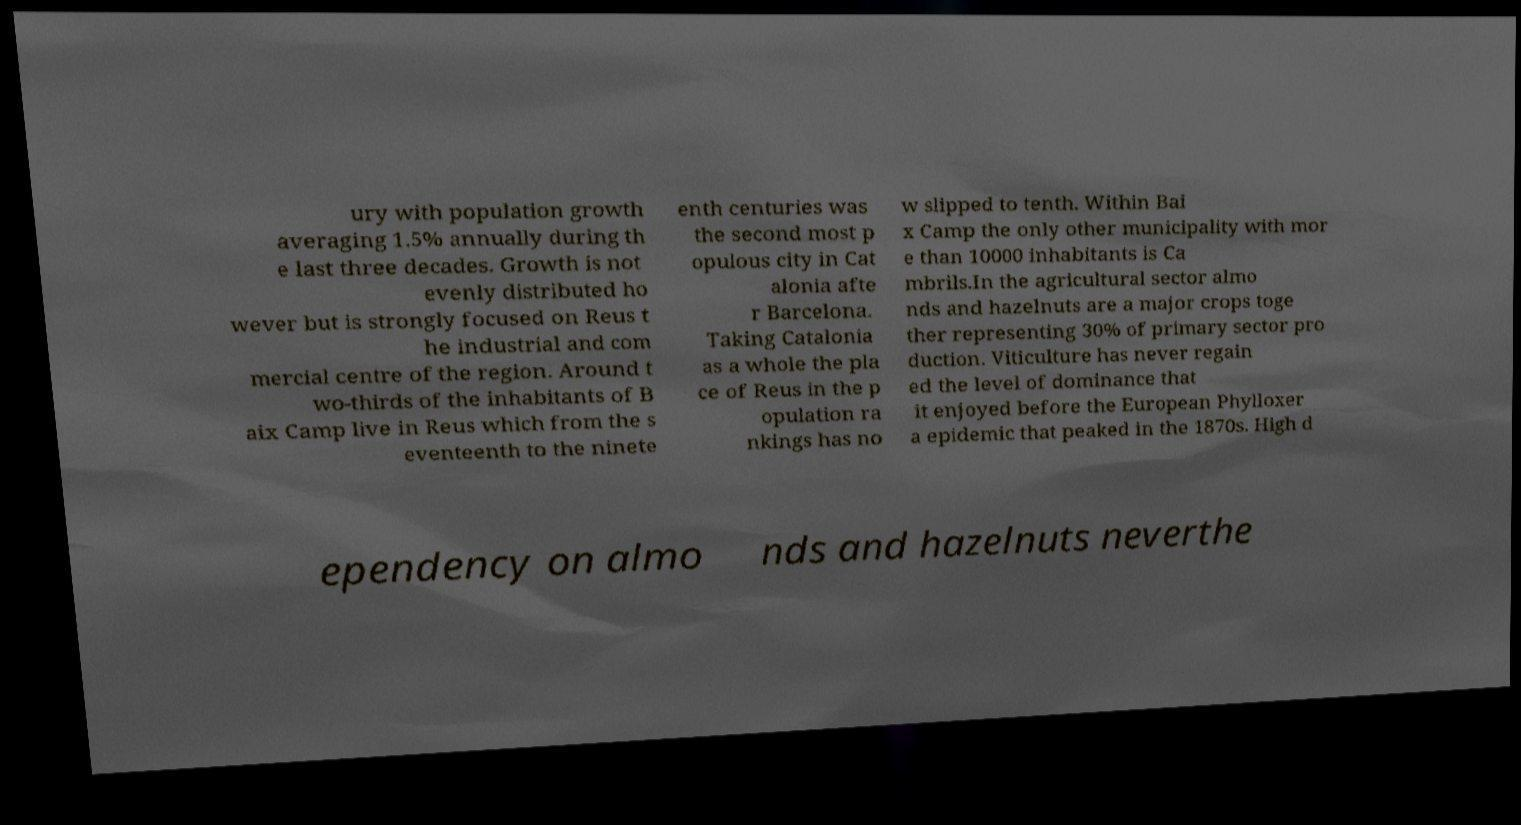There's text embedded in this image that I need extracted. Can you transcribe it verbatim? ury with population growth averaging 1.5% annually during th e last three decades. Growth is not evenly distributed ho wever but is strongly focused on Reus t he industrial and com mercial centre of the region. Around t wo-thirds of the inhabitants of B aix Camp live in Reus which from the s eventeenth to the ninete enth centuries was the second most p opulous city in Cat alonia afte r Barcelona. Taking Catalonia as a whole the pla ce of Reus in the p opulation ra nkings has no w slipped to tenth. Within Bai x Camp the only other municipality with mor e than 10000 inhabitants is Ca mbrils.In the agricultural sector almo nds and hazelnuts are a major crops toge ther representing 30% of primary sector pro duction. Viticulture has never regain ed the level of dominance that it enjoyed before the European Phylloxer a epidemic that peaked in the 1870s. High d ependency on almo nds and hazelnuts neverthe 